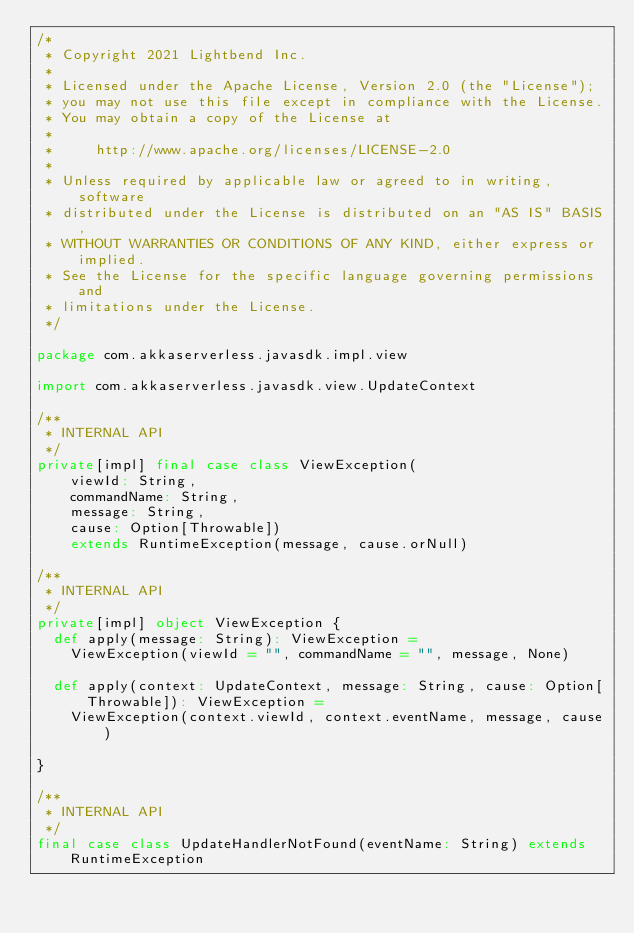<code> <loc_0><loc_0><loc_500><loc_500><_Scala_>/*
 * Copyright 2021 Lightbend Inc.
 *
 * Licensed under the Apache License, Version 2.0 (the "License");
 * you may not use this file except in compliance with the License.
 * You may obtain a copy of the License at
 *
 *     http://www.apache.org/licenses/LICENSE-2.0
 *
 * Unless required by applicable law or agreed to in writing, software
 * distributed under the License is distributed on an "AS IS" BASIS,
 * WITHOUT WARRANTIES OR CONDITIONS OF ANY KIND, either express or implied.
 * See the License for the specific language governing permissions and
 * limitations under the License.
 */

package com.akkaserverless.javasdk.impl.view

import com.akkaserverless.javasdk.view.UpdateContext

/**
 * INTERNAL API
 */
private[impl] final case class ViewException(
    viewId: String,
    commandName: String,
    message: String,
    cause: Option[Throwable])
    extends RuntimeException(message, cause.orNull)

/**
 * INTERNAL API
 */
private[impl] object ViewException {
  def apply(message: String): ViewException =
    ViewException(viewId = "", commandName = "", message, None)

  def apply(context: UpdateContext, message: String, cause: Option[Throwable]): ViewException =
    ViewException(context.viewId, context.eventName, message, cause)

}

/**
 * INTERNAL API
 */
final case class UpdateHandlerNotFound(eventName: String) extends RuntimeException
</code> 